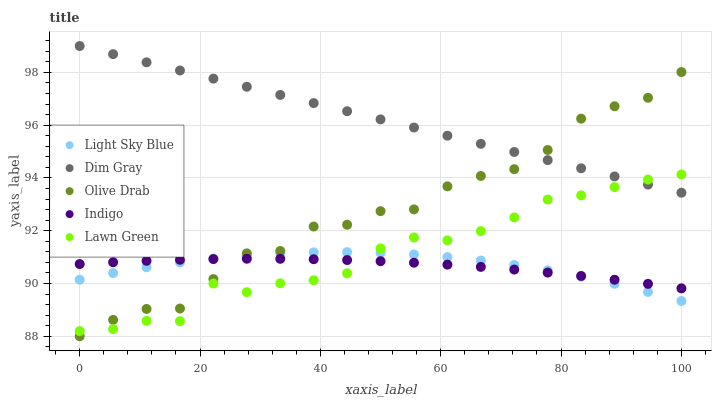Does Indigo have the minimum area under the curve?
Answer yes or no. Yes. Does Dim Gray have the maximum area under the curve?
Answer yes or no. Yes. Does Light Sky Blue have the minimum area under the curve?
Answer yes or no. No. Does Light Sky Blue have the maximum area under the curve?
Answer yes or no. No. Is Dim Gray the smoothest?
Answer yes or no. Yes. Is Olive Drab the roughest?
Answer yes or no. Yes. Is Light Sky Blue the smoothest?
Answer yes or no. No. Is Light Sky Blue the roughest?
Answer yes or no. No. Does Olive Drab have the lowest value?
Answer yes or no. Yes. Does Light Sky Blue have the lowest value?
Answer yes or no. No. Does Dim Gray have the highest value?
Answer yes or no. Yes. Does Light Sky Blue have the highest value?
Answer yes or no. No. Is Light Sky Blue less than Dim Gray?
Answer yes or no. Yes. Is Dim Gray greater than Light Sky Blue?
Answer yes or no. Yes. Does Indigo intersect Olive Drab?
Answer yes or no. Yes. Is Indigo less than Olive Drab?
Answer yes or no. No. Is Indigo greater than Olive Drab?
Answer yes or no. No. Does Light Sky Blue intersect Dim Gray?
Answer yes or no. No. 